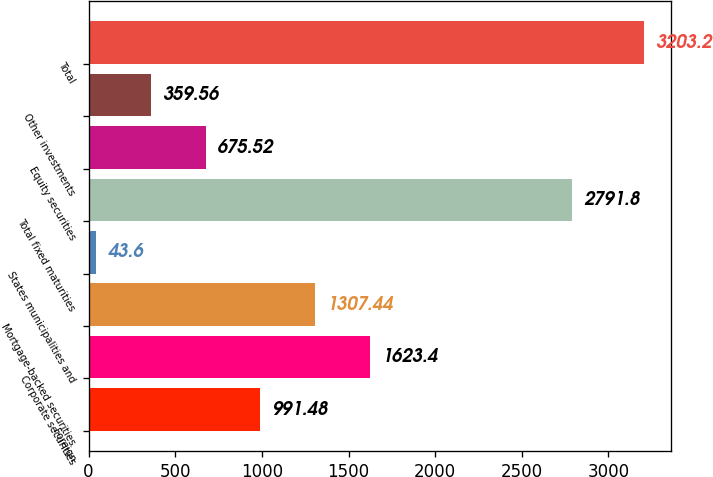Convert chart. <chart><loc_0><loc_0><loc_500><loc_500><bar_chart><fcel>Foreign<fcel>Corporate securities<fcel>Mortgage-backed securities<fcel>States municipalities and<fcel>Total fixed maturities<fcel>Equity securities<fcel>Other investments<fcel>Total<nl><fcel>991.48<fcel>1623.4<fcel>1307.44<fcel>43.6<fcel>2791.8<fcel>675.52<fcel>359.56<fcel>3203.2<nl></chart> 